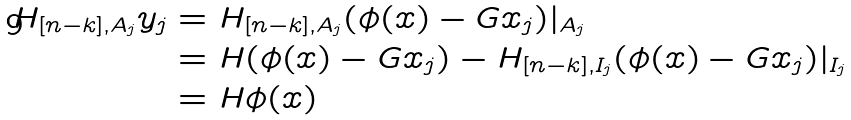Convert formula to latex. <formula><loc_0><loc_0><loc_500><loc_500>H _ { [ n - k ] , A _ { j } } y _ { j } & = H _ { [ n - k ] , A _ { j } } ( \phi ( x ) - G x _ { j } ) | _ { A _ { j } } \\ & = H ( \phi ( x ) - G x _ { j } ) - H _ { [ n - k ] , I _ { j } } ( \phi ( x ) - G x _ { j } ) | _ { I _ { j } } \\ & = H \phi ( x )</formula> 